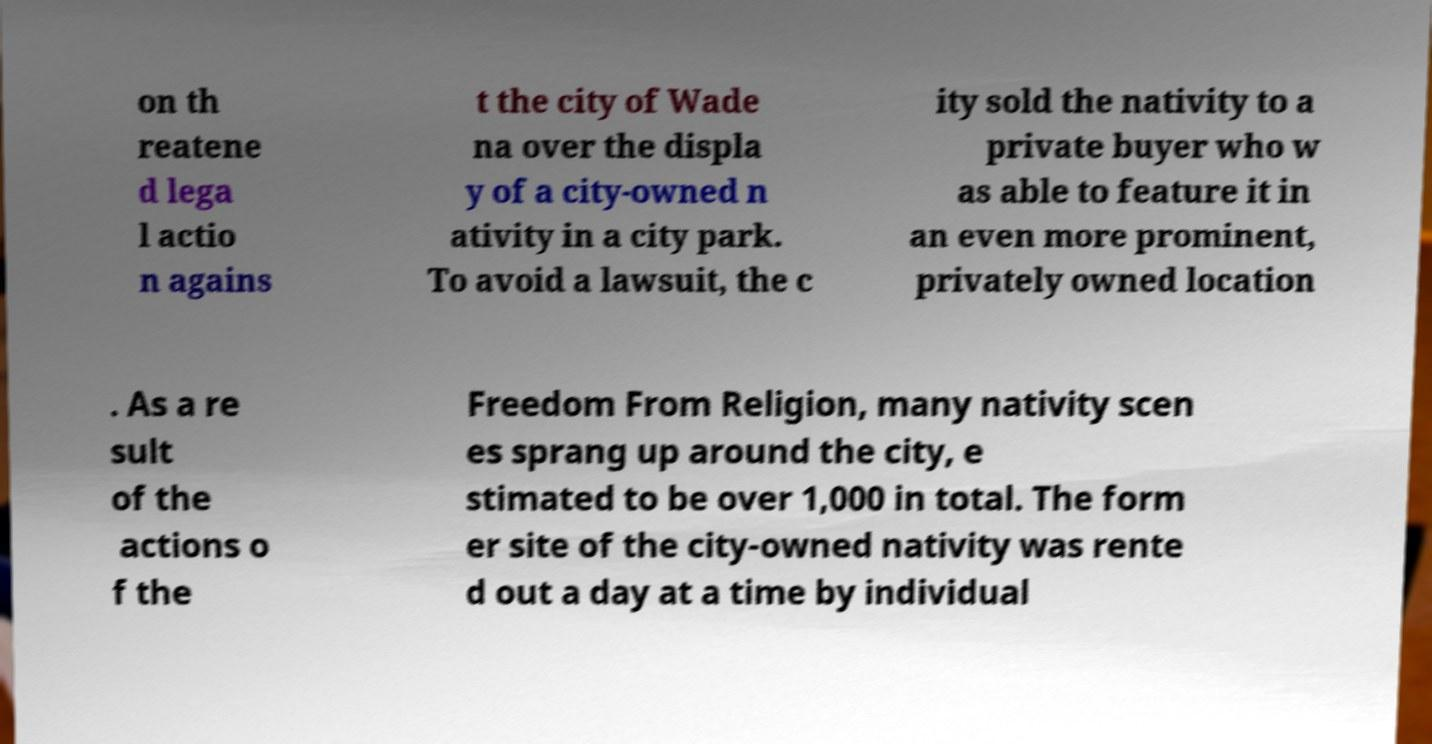I need the written content from this picture converted into text. Can you do that? on th reatene d lega l actio n agains t the city of Wade na over the displa y of a city-owned n ativity in a city park. To avoid a lawsuit, the c ity sold the nativity to a private buyer who w as able to feature it in an even more prominent, privately owned location . As a re sult of the actions o f the Freedom From Religion, many nativity scen es sprang up around the city, e stimated to be over 1,000 in total. The form er site of the city-owned nativity was rente d out a day at a time by individual 